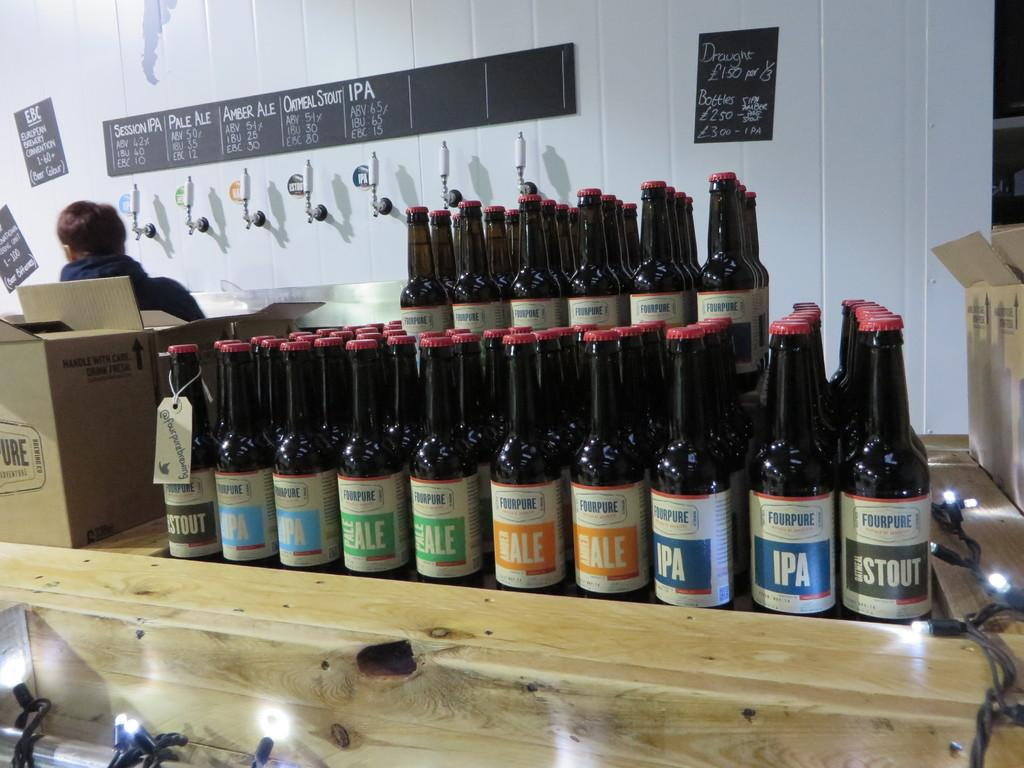<image>
Present a compact description of the photo's key features. many bottles of FourPure beer are lined up on a counter 